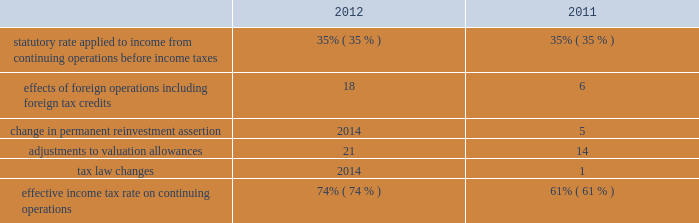Provision for income taxes increased $ 1791 million in 2012 from 2011 primarily due to the increase in pretax income from continuing operations , including the impact of the resumption of sales in libya in the first quarter of 2012 .
The following is an analysis of the effective income tax rates for 2012 and 2011: .
The effective income tax rate is influenced by a variety of factors including the geographic sources of income and the relative magnitude of these sources of income .
The provision for income taxes is allocated on a discrete , stand-alone basis to pretax segment income and to individual items not allocated to segments .
The difference between the total provision and the sum of the amounts allocated to segments appears in the "corporate and other unallocated items" shown in the reconciliation of segment income to net income below .
Effects of foreign operations 2013 the effects of foreign operations on our effective tax rate increased in 2012 as compared to 2011 , primarily due to the resumption of sales in libya in the first quarter of 2012 , where the statutory rate is in excess of 90 percent .
Change in permanent reinvestment assertion 2013 in the second quarter of 2011 , we recorded $ 716 million of deferred u.s .
Tax on undistributed earnings of $ 2046 million that we previously intended to permanently reinvest in foreign operations .
Offsetting this tax expense were associated foreign tax credits of $ 488 million .
In addition , we reduced our valuation allowance related to foreign tax credits by $ 228 million due to recognizing deferred u.s .
Tax on previously undistributed earnings .
Adjustments to valuation allowances 2013 in 2012 and 2011 , we increased the valuation allowance against foreign tax credits because it is more likely than not that we will be unable to realize all u.s .
Benefits on foreign taxes accrued in those years .
See item 8 .
Financial statements and supplementary data - note 10 to the consolidated financial statements for further information about income taxes .
Discontinued operations is presented net of tax , and reflects our downstream business that was spun off june 30 , 2011 and our angola business which we agreed to sell in 2013 .
See item 8 .
Financial statements and supplementary data 2013 notes 3 and 6 to the consolidated financial statements for additional information. .
By what percentage did adjustments to valuation allowances increase from 2011 to 2012>? 
Computations: ((21 - 14) / 14)
Answer: 0.5. 